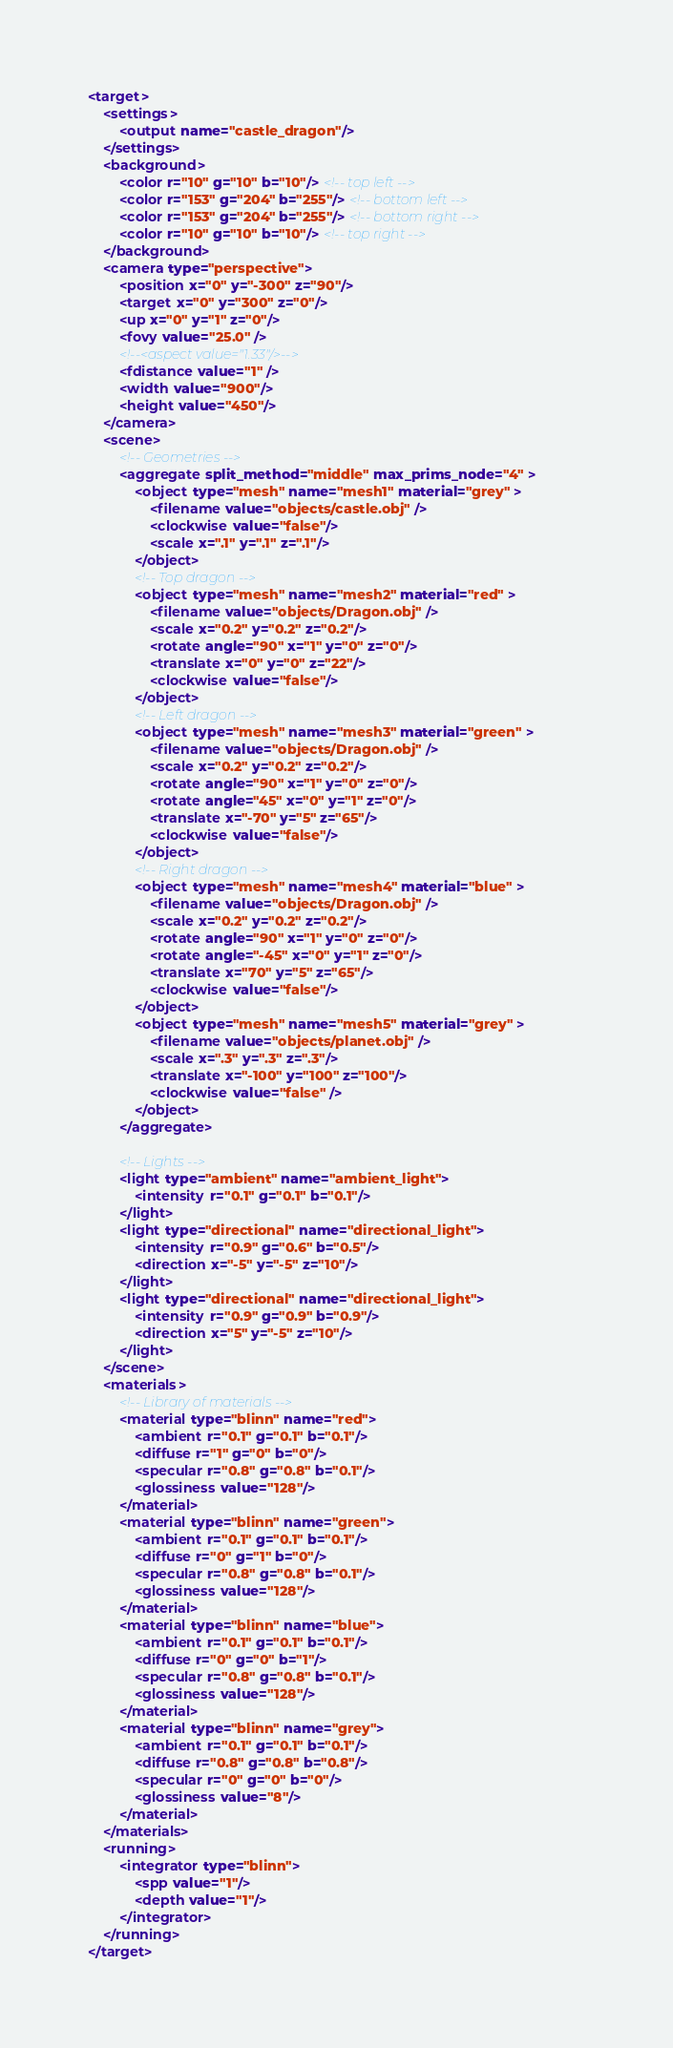Convert code to text. <code><loc_0><loc_0><loc_500><loc_500><_XML_><target>
    <settings>
        <output name="castle_dragon"/>
    </settings>
    <background>
        <color r="10" g="10" b="10"/> <!-- top left -->
        <color r="153" g="204" b="255"/> <!-- bottom left -->
        <color r="153" g="204" b="255"/> <!-- bottom right -->
        <color r="10" g="10" b="10"/> <!-- top right -->
    </background>
    <camera type="perspective">
        <position x="0" y="-300" z="90"/> 
        <target x="0" y="300" z="0"/>
        <up x="0" y="1" z="0"/>
        <fovy value="25.0" />
        <!--<aspect value="1.33"/>-->
        <fdistance value="1" />
        <width value="900"/>
        <height value="450"/>
    </camera>
    <scene>
        <!-- Geometries -->
        <aggregate split_method="middle" max_prims_node="4" >
            <object type="mesh" name="mesh1" material="grey" >             
                <filename value="objects/castle.obj" />
                <clockwise value="false"/>
                <scale x=".1" y=".1" z=".1"/> 
            </object>
            <!-- Top dragon -->
            <object type="mesh" name="mesh2" material="red" >             
                <filename value="objects/Dragon.obj" />
                <scale x="0.2" y="0.2" z="0.2"/>
                <rotate angle="90" x="1" y="0" z="0"/>
                <translate x="0" y="0" z="22"/>
                <clockwise value="false"/> 
            </object>
            <!-- Left dragon -->
            <object type="mesh" name="mesh3" material="green" >             
                <filename value="objects/Dragon.obj" />
                <scale x="0.2" y="0.2" z="0.2"/>
                <rotate angle="90" x="1" y="0" z="0"/>
                <rotate angle="45" x="0" y="1" z="0"/>
                <translate x="-70" y="5" z="65"/>
                <clockwise value="false"/> 
            </object>
            <!-- Right dragon -->
            <object type="mesh" name="mesh4" material="blue" >             
                <filename value="objects/Dragon.obj" />
                <scale x="0.2" y="0.2" z="0.2"/>
                <rotate angle="90" x="1" y="0" z="0"/>
                <rotate angle="-45" x="0" y="1" z="0"/>
                <translate x="70" y="5" z="65"/>
                <clockwise value="false"/> 
            </object>
            <object type="mesh" name="mesh5" material="grey" >             
                <filename value="objects/planet.obj" />
                <scale x=".3" y=".3" z=".3"/>
                <translate x="-100" y="100" z="100"/>
                <clockwise value="false" />
            </object>
        </aggregate>
        
        <!-- Lights -->
        <light type="ambient" name="ambient_light">             
            <intensity r="0.1" g="0.1" b="0.1"/>         
        </light>         
        <light type="directional" name="directional_light">             
            <intensity r="0.9" g="0.6" b="0.5"/>             
            <direction x="-5" y="-5" z="10"/>         
        </light>         
        <light type="directional" name="directional_light">             
            <intensity r="0.9" g="0.9" b="0.9"/>             
            <direction x="5" y="-5" z="10"/>         
        </light>
    </scene>
    <materials>
        <!-- Library of materials -->
        <material type="blinn" name="red">
            <ambient r="0.1" g="0.1" b="0.1"/>
            <diffuse r="1" g="0" b="0"/>
            <specular r="0.8" g="0.8" b="0.1"/>
            <glossiness value="128"/>
        </material>
        <material type="blinn" name="green">
            <ambient r="0.1" g="0.1" b="0.1"/>
            <diffuse r="0" g="1" b="0"/>
            <specular r="0.8" g="0.8" b="0.1"/>
            <glossiness value="128"/>
        </material>
        <material type="blinn" name="blue">
            <ambient r="0.1" g="0.1" b="0.1"/>
            <diffuse r="0" g="0" b="1"/>
            <specular r="0.8" g="0.8" b="0.1"/>
            <glossiness value="128"/>
        </material>
        <material type="blinn" name="grey">
            <ambient r="0.1" g="0.1" b="0.1"/>
            <diffuse r="0.8" g="0.8" b="0.8"/>
            <specular r="0" g="0" b="0"/>
            <glossiness value="8"/>
        </material>
    </materials>
    <running>
        <integrator type="blinn">
            <spp value="1"/>
            <depth value="1"/>
        </integrator>
    </running>
</target>
</code> 